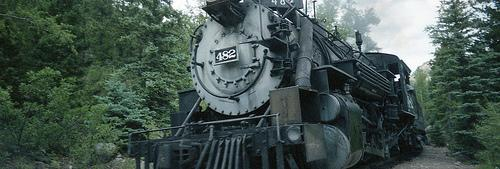Describe the front part of the train in a conversational tone. So, we've got this cool black train here, right? Its front has a grate, a headlight, and it's got the number 482 on it too! Write a poetic description of the image. Through green realms of whispering pines, a mighty iron horse forges its path, hazy smoke trailing behind its blackened form. Mention a specific feature of the train and its surroundings. The train has a number plate on the front, displaying the white number "482" against a black background. Describe the image in a journalistic style. A historic steam locomotive, numbered 482, journeys through a scenic forest, billowing wisps of grey smoke against the cloud-filled sky above. Comment on the train's engine and the presence of smoke in the image The train's engine is emitting hazy grey smoke, which can be seen billowing into the cloudy sky above the forest. Explain the color scheme of the train and its surroundings The black train with white numbering contrasts with the vibrant green of the surrounding pine trees and the gray of nearby rocks. Provide a brief overview of the scene in this image. A black train is going through a forest, surrounded by pine trees and rocks, with smoke coming from the engine. Describe the most distinctive features of the train in this image The black train has a large front grate, a prominent headlight, and the number 482 in white numerals on its front. Provide a simple overview of the scene in the image A black steam train is traveling through a forest with pine trees, rocks, and smoke Describe the train's appearance and its surroundings in a detailed manner. The black steam train has a front grate, headlight, and number 482 on it, moving through a lush forest with pine trees and gray rocks near the tracks. 